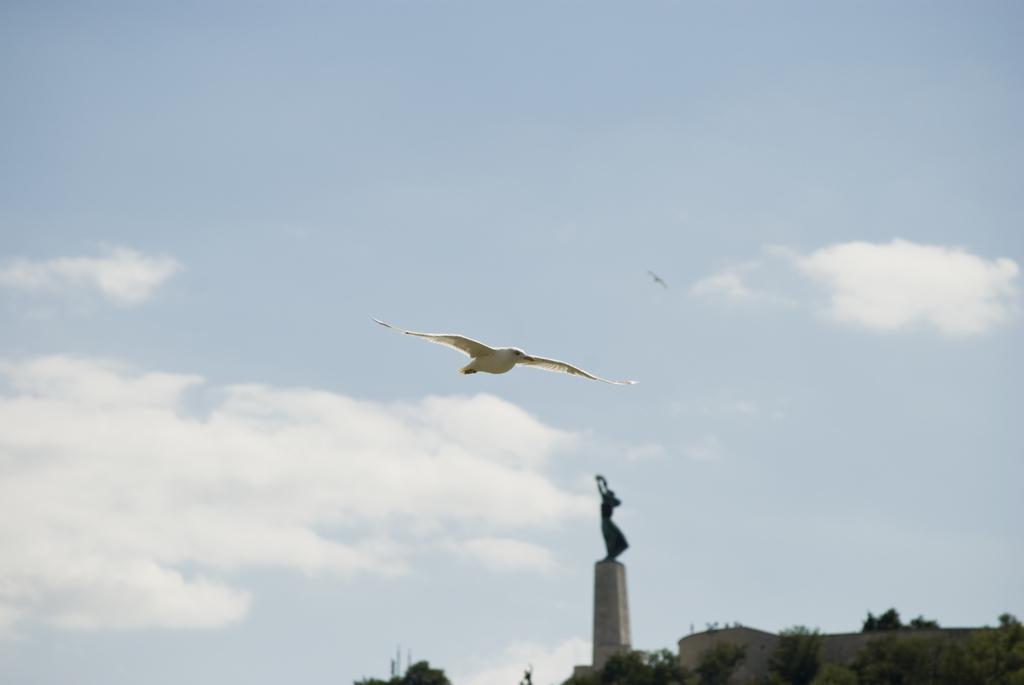Describe this image in one or two sentences. In the picture I can see a bird is flying in the air and there is a statue and few trees in the background and the sky is a bit cloudy. 